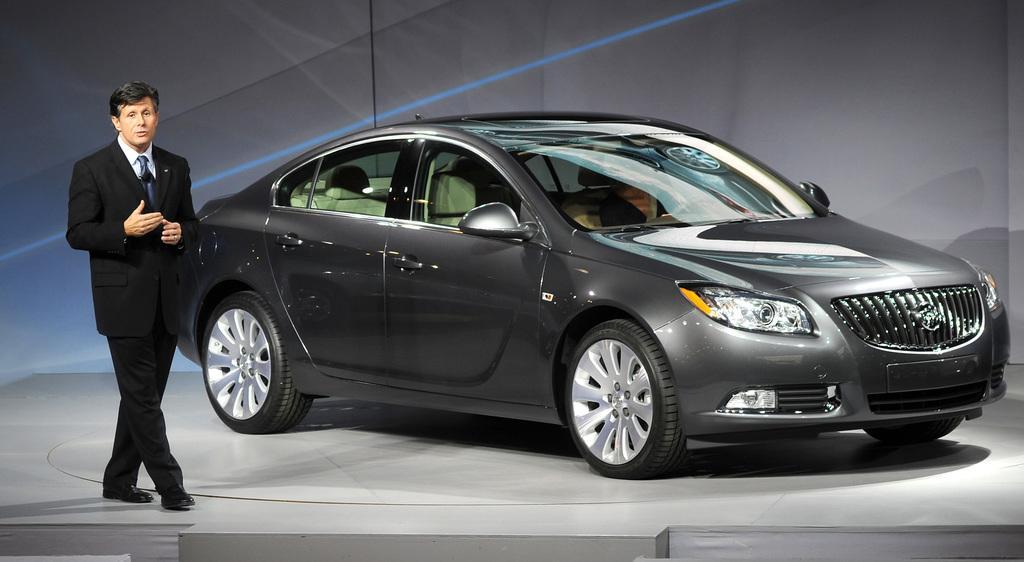Can you describe this image briefly? In this image we can see a car and man. He is wearing white color suit with white shirt and tie. Background of the image grey color wall is present. 